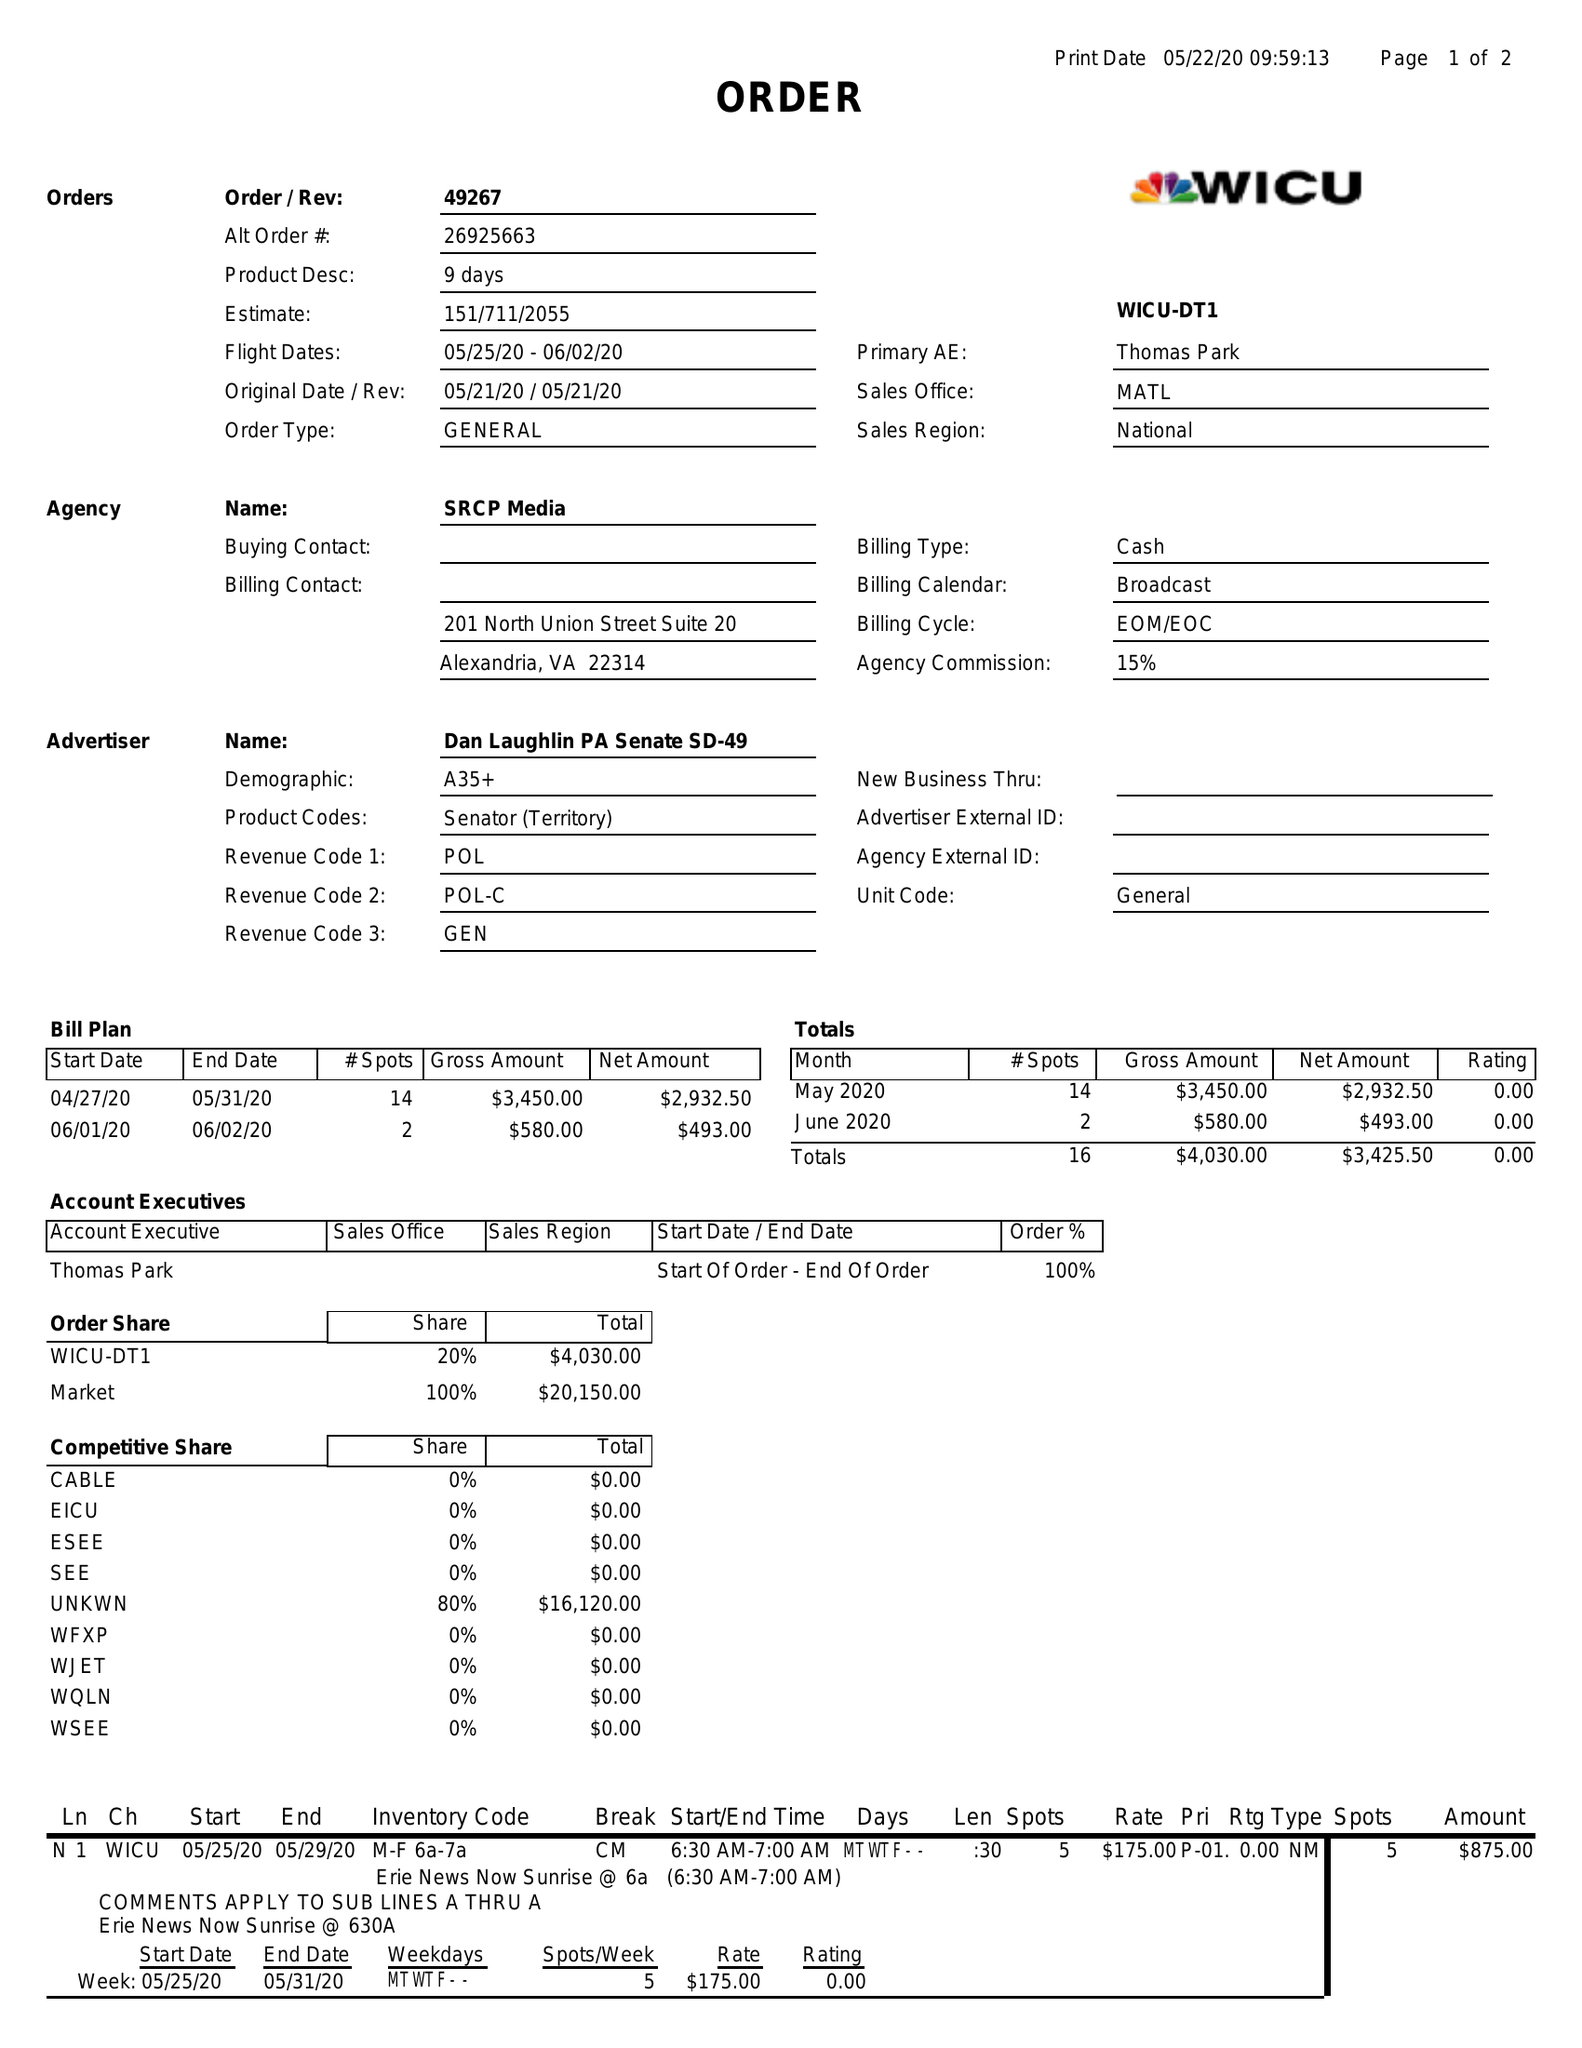What is the value for the flight_from?
Answer the question using a single word or phrase. 05/25/20 